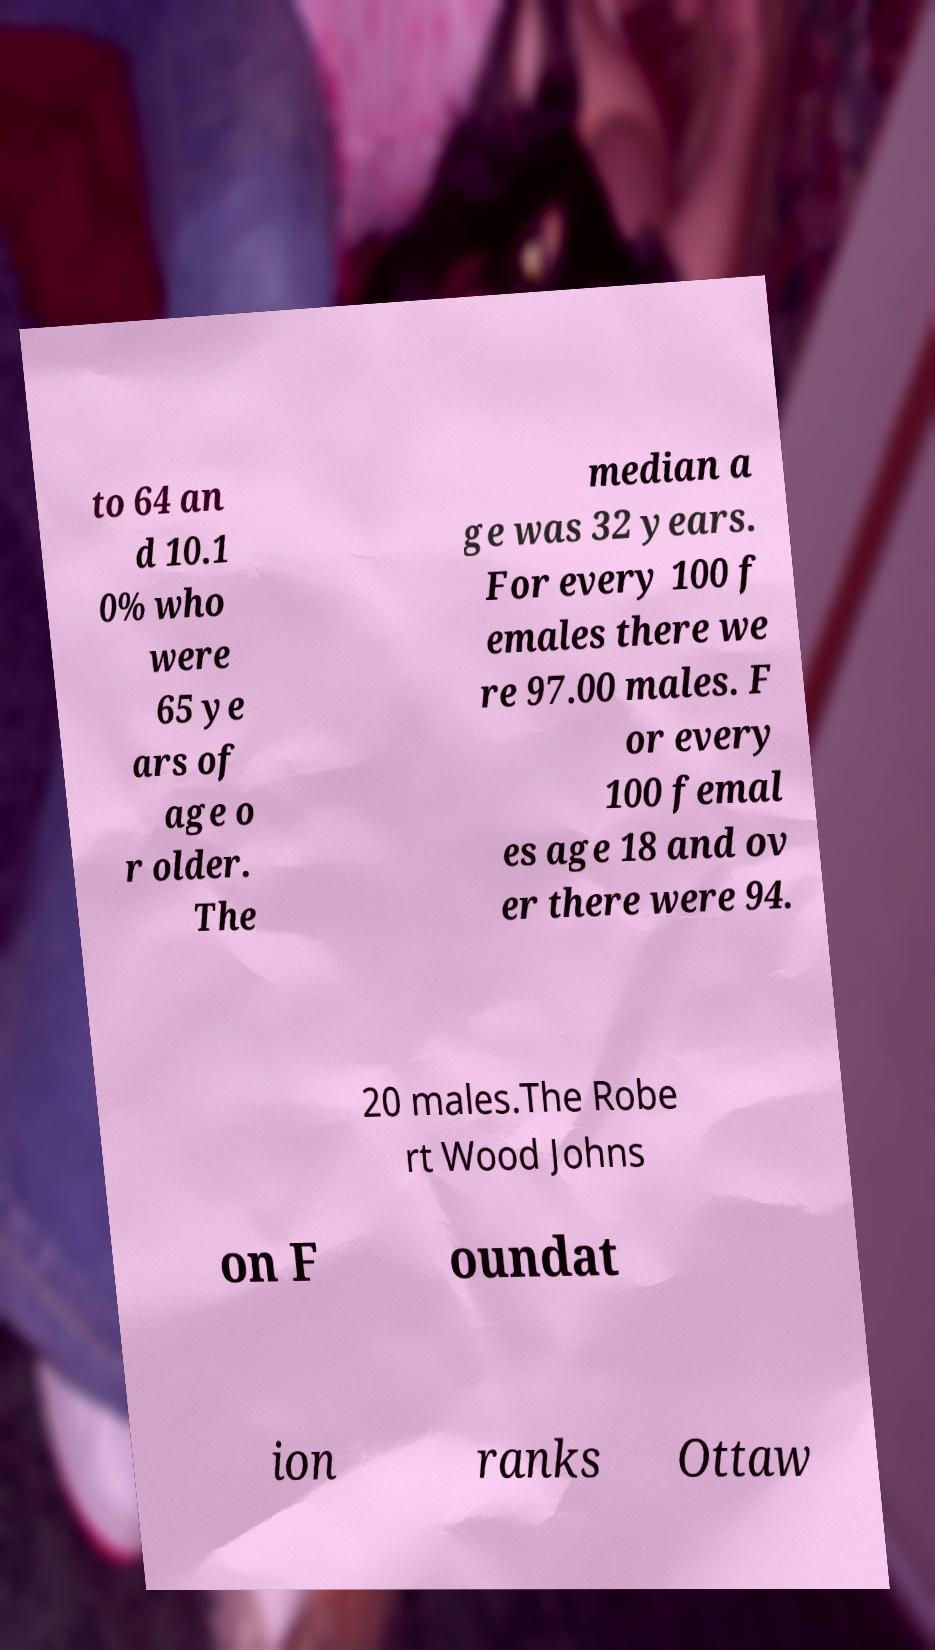There's text embedded in this image that I need extracted. Can you transcribe it verbatim? to 64 an d 10.1 0% who were 65 ye ars of age o r older. The median a ge was 32 years. For every 100 f emales there we re 97.00 males. F or every 100 femal es age 18 and ov er there were 94. 20 males.The Robe rt Wood Johns on F oundat ion ranks Ottaw 